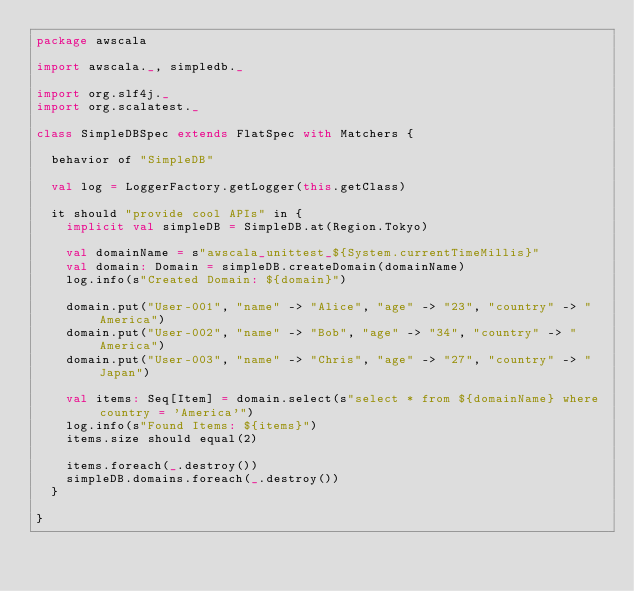Convert code to text. <code><loc_0><loc_0><loc_500><loc_500><_Scala_>package awscala

import awscala._, simpledb._

import org.slf4j._
import org.scalatest._

class SimpleDBSpec extends FlatSpec with Matchers {

  behavior of "SimpleDB"

  val log = LoggerFactory.getLogger(this.getClass)

  it should "provide cool APIs" in {
    implicit val simpleDB = SimpleDB.at(Region.Tokyo)

    val domainName = s"awscala_unittest_${System.currentTimeMillis}"
    val domain: Domain = simpleDB.createDomain(domainName)
    log.info(s"Created Domain: ${domain}")

    domain.put("User-001", "name" -> "Alice", "age" -> "23", "country" -> "America")
    domain.put("User-002", "name" -> "Bob", "age" -> "34", "country" -> "America")
    domain.put("User-003", "name" -> "Chris", "age" -> "27", "country" -> "Japan")

    val items: Seq[Item] = domain.select(s"select * from ${domainName} where country = 'America'")
    log.info(s"Found Items: ${items}")
    items.size should equal(2)

    items.foreach(_.destroy())
    simpleDB.domains.foreach(_.destroy())
  }

}
</code> 